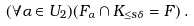Convert formula to latex. <formula><loc_0><loc_0><loc_500><loc_500>( \forall \alpha \in U _ { 2 } ) ( F _ { \alpha } \cap K _ { \leq s \delta } = F ) \, .</formula> 